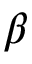<formula> <loc_0><loc_0><loc_500><loc_500>\beta</formula> 